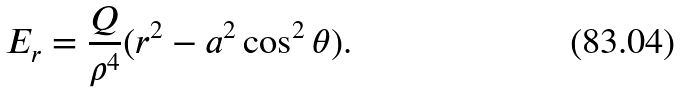Convert formula to latex. <formula><loc_0><loc_0><loc_500><loc_500>E _ { r } = \frac { Q } { \rho ^ { 4 } } ( r ^ { 2 } - a ^ { 2 } \cos ^ { 2 } \theta ) .</formula> 